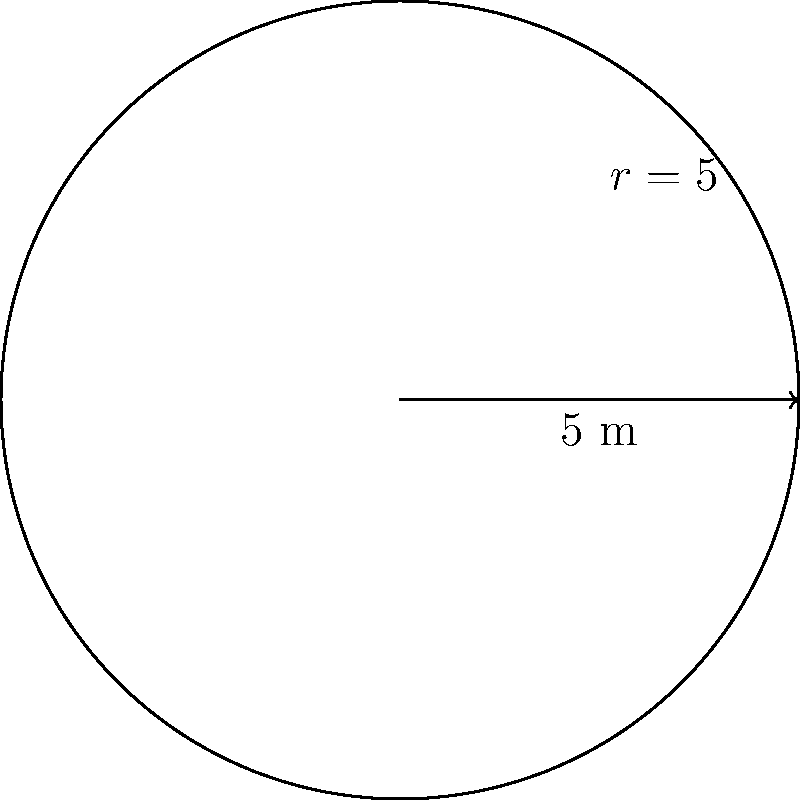A Celtic roundhouse in ancient Cumbria has a circular floor plan with a radius of 5 meters. Using polar integration, calculate the area of the roundhouse floor. Round your answer to the nearest whole number. To calculate the area of the Celtic roundhouse using polar integration, we follow these steps:

1) The general formula for area using polar coordinates is:

   $$A = \frac{1}{2} \int_{0}^{2\pi} r^2(\theta) d\theta$$

2) In this case, the radius is constant (r = 5), so our function is simply r(θ) = 5.

3) Substituting this into our formula:

   $$A = \frac{1}{2} \int_{0}^{2\pi} 5^2 d\theta$$

4) Simplify:

   $$A = \frac{1}{2} \int_{0}^{2\pi} 25 d\theta$$

5) Integrate:

   $$A = \frac{1}{2} [25\theta]_{0}^{2\pi}$$

6) Evaluate the definite integral:

   $$A = \frac{1}{2} [25(2\pi) - 25(0)] = \frac{1}{2} (50\pi)$$

7) Simplify:

   $$A = 25\pi$$

8) Calculate and round to the nearest whole number:

   $$A ≈ 78.54 \approx 79 \text{ square meters}$$
Answer: 79 square meters 